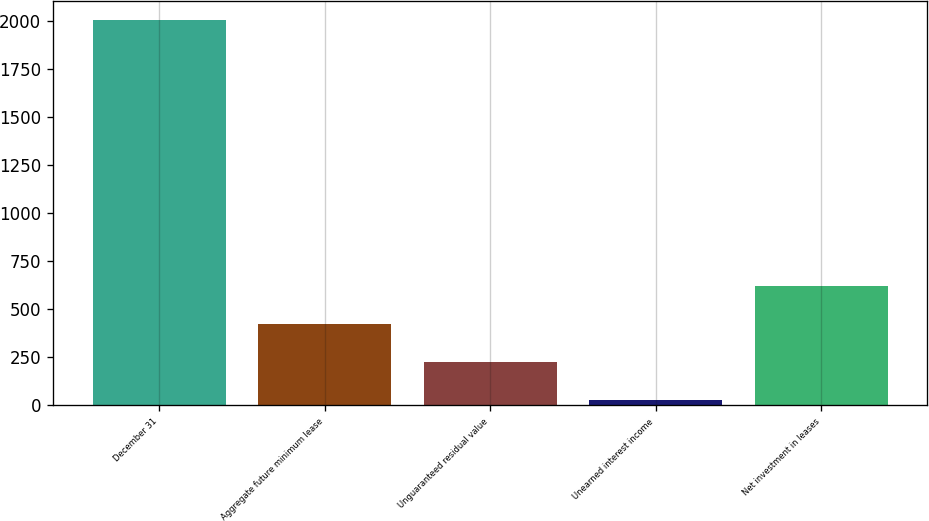<chart> <loc_0><loc_0><loc_500><loc_500><bar_chart><fcel>December 31<fcel>Aggregate future minimum lease<fcel>Unguaranteed residual value<fcel>Unearned interest income<fcel>Net investment in leases<nl><fcel>2005<fcel>424.2<fcel>226.6<fcel>29<fcel>621.8<nl></chart> 